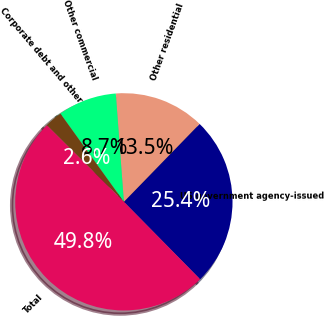<chart> <loc_0><loc_0><loc_500><loc_500><pie_chart><fcel>US government agency-issued<fcel>Other residential<fcel>Other commercial<fcel>Corporate debt and other<fcel>Total<nl><fcel>25.35%<fcel>13.46%<fcel>8.74%<fcel>2.62%<fcel>49.83%<nl></chart> 